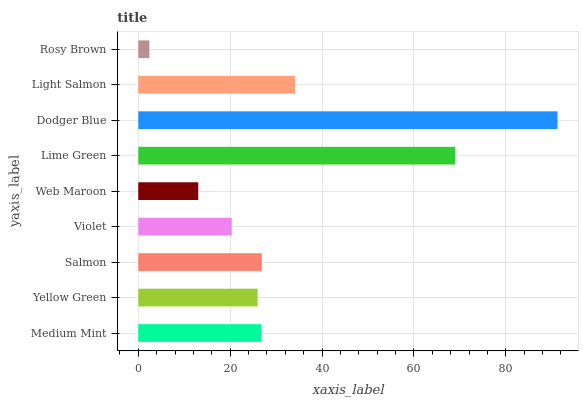Is Rosy Brown the minimum?
Answer yes or no. Yes. Is Dodger Blue the maximum?
Answer yes or no. Yes. Is Yellow Green the minimum?
Answer yes or no. No. Is Yellow Green the maximum?
Answer yes or no. No. Is Medium Mint greater than Yellow Green?
Answer yes or no. Yes. Is Yellow Green less than Medium Mint?
Answer yes or no. Yes. Is Yellow Green greater than Medium Mint?
Answer yes or no. No. Is Medium Mint less than Yellow Green?
Answer yes or no. No. Is Medium Mint the high median?
Answer yes or no. Yes. Is Medium Mint the low median?
Answer yes or no. Yes. Is Light Salmon the high median?
Answer yes or no. No. Is Lime Green the low median?
Answer yes or no. No. 